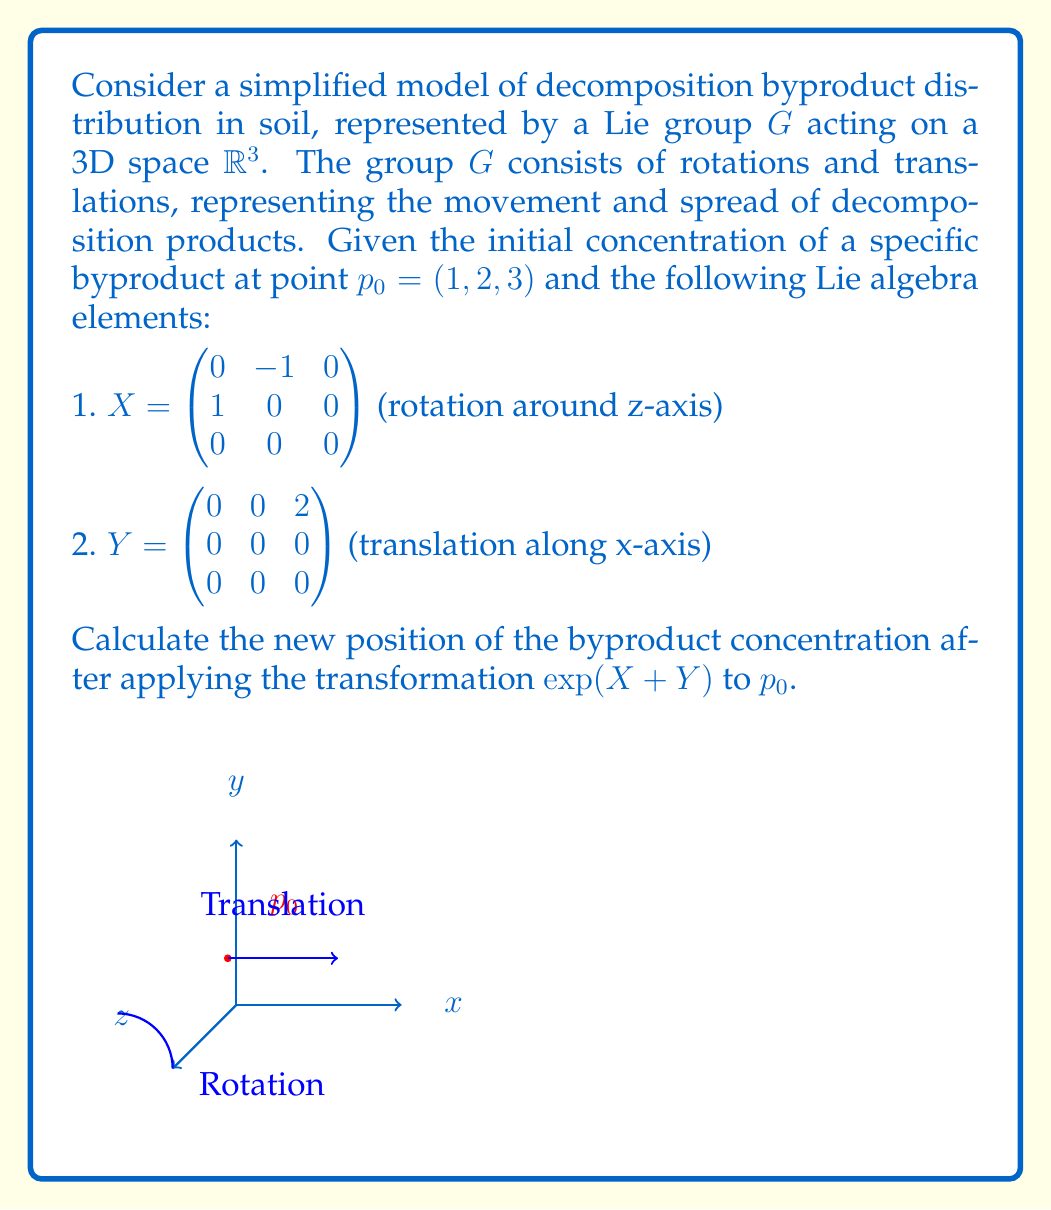Provide a solution to this math problem. To solve this problem, we'll use the Baker-Campbell-Hausdorff formula and the properties of Lie group transformations:

1) First, we need to compute $\exp(X + Y)$. Using the Baker-Campbell-Hausdorff formula:

   $$\exp(X + Y) \approx \exp(X)\exp(Y)\exp(-\frac{1}{2}[X,Y])$$

2) Calculate $\exp(X)$:
   $$\exp(X) = \begin{pmatrix}\cos 1 & -\sin 1 & 0 \\ \sin 1 & \cos 1 & 0 \\ 0 & 0 & 1\end{pmatrix}$$

3) Calculate $\exp(Y)$:
   $$\exp(Y) = \begin{pmatrix}1 & 0 & 2 \\ 0 & 1 & 0 \\ 0 & 0 & 1\end{pmatrix}$$

4) Calculate the commutator $[X,Y]$:
   $$[X,Y] = XY - YX = \begin{pmatrix}0 & 0 & 0 \\ 2 & 0 & 0 \\ 0 & 0 & 0\end{pmatrix}$$

5) Calculate $\exp(-\frac{1}{2}[X,Y])$:
   $$\exp(-\frac{1}{2}[X,Y]) = \begin{pmatrix}1 & 0 & 0 \\ -1 & 1 & 0 \\ 0 & 0 & 1\end{pmatrix}$$

6) Multiply the matrices:
   $$\exp(X + Y) \approx \begin{pmatrix}\cos 1 & -\sin 1 & 2\cos 1 \\ \sin 1 & \cos 1 & 2\sin 1 \\ 0 & 0 & 1\end{pmatrix}$$

7) Apply the transformation to $p_0$:
   $$\begin{pmatrix}\cos 1 & -\sin 1 & 2\cos 1 \\ \sin 1 & \cos 1 & 2\sin 1 \\ 0 & 0 & 1\end{pmatrix} \begin{pmatrix}1 \\ 2 \\ 3\end{pmatrix} = \begin{pmatrix}\cos 1 - 2\sin 1 + 2\cos 1 \\ \sin 1 + 2\cos 1 + 2\sin 1 \\ 3\end{pmatrix}$$

8) Simplify:
   $$\begin{pmatrix}3\cos 1 - 2\sin 1 \\ 3\sin 1 + 2\cos 1 \\ 3\end{pmatrix}$$
Answer: $(3\cos 1 - 2\sin 1, 3\sin 1 + 2\cos 1, 3)$ 